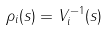Convert formula to latex. <formula><loc_0><loc_0><loc_500><loc_500>\rho _ { i } ( s ) = V _ { i } ^ { - 1 } ( s )</formula> 